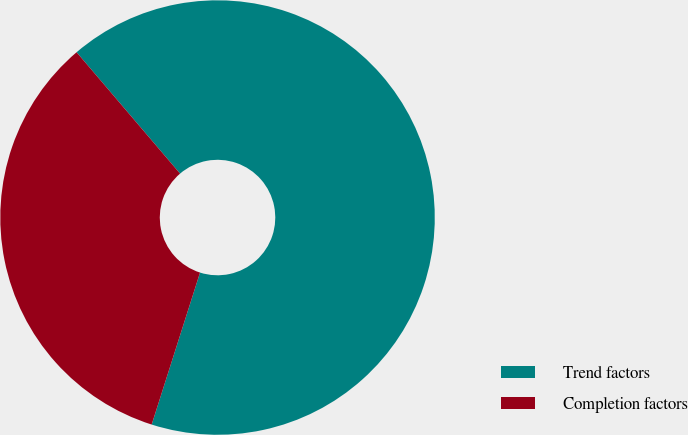<chart> <loc_0><loc_0><loc_500><loc_500><pie_chart><fcel>Trend factors<fcel>Completion factors<nl><fcel>66.14%<fcel>33.86%<nl></chart> 